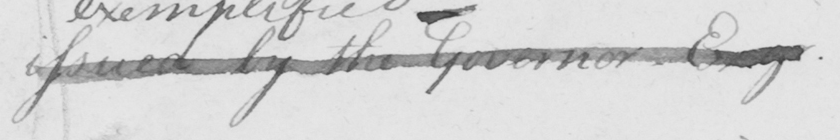What is written in this line of handwriting? issued by the Governor Esq . 